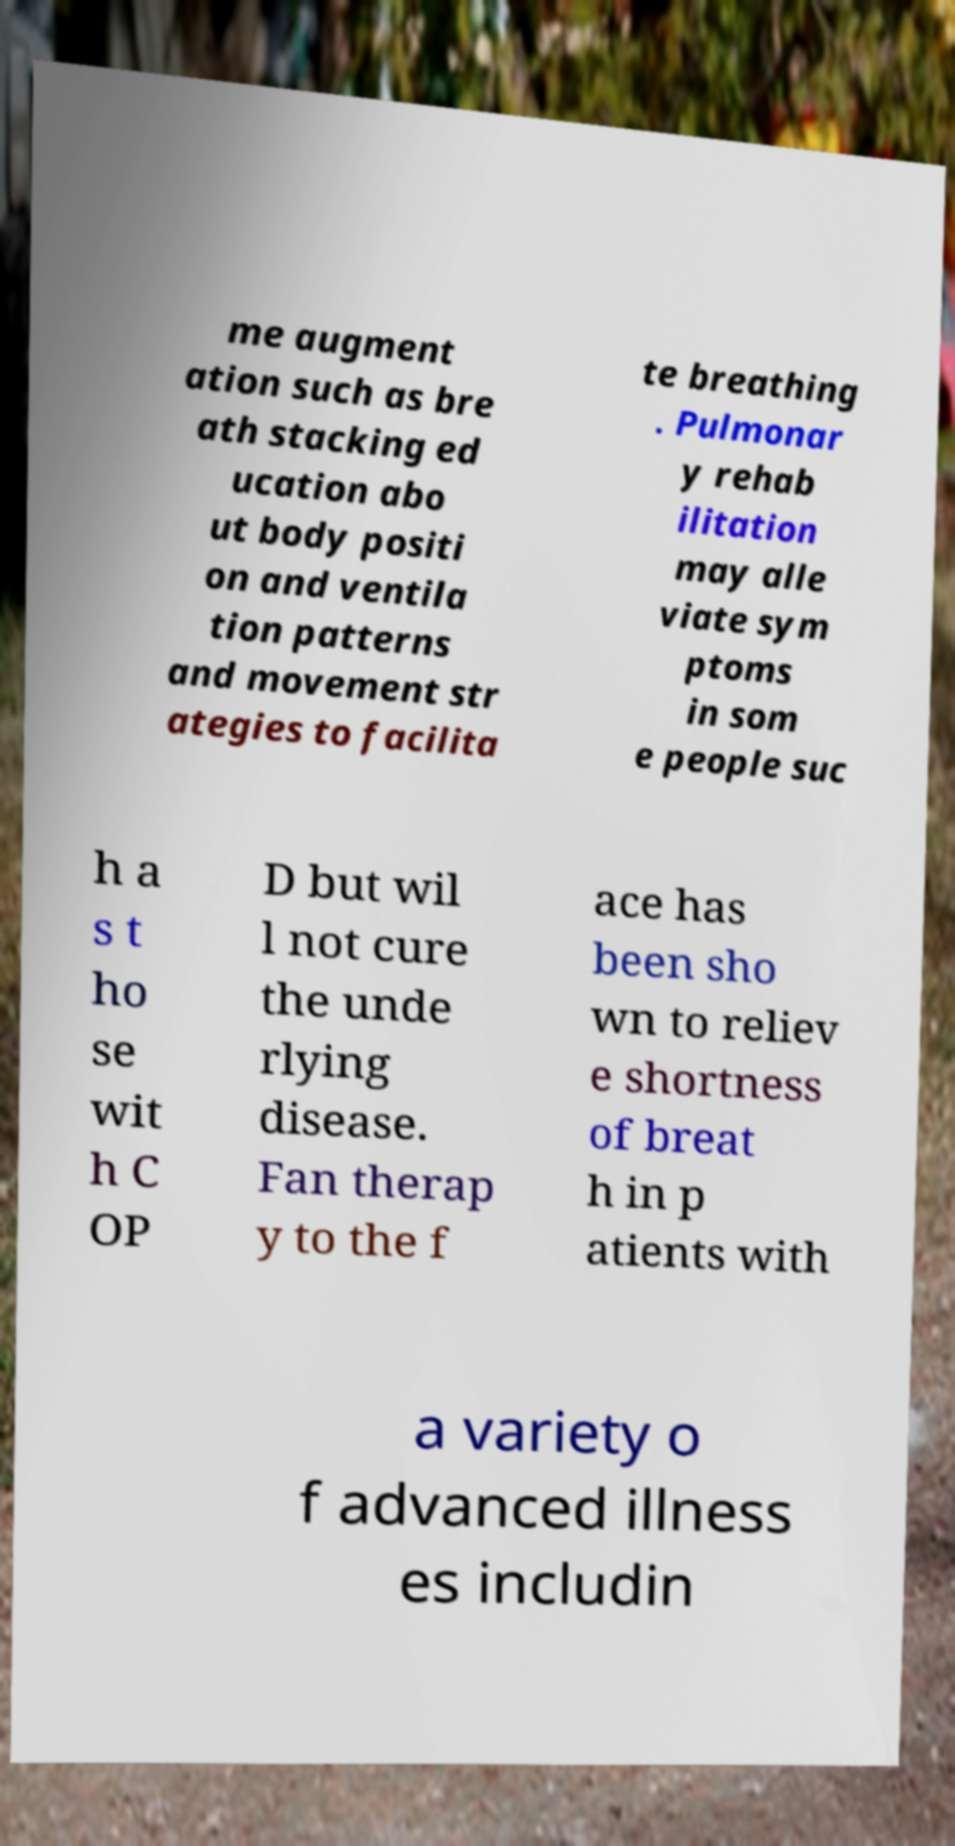What messages or text are displayed in this image? I need them in a readable, typed format. me augment ation such as bre ath stacking ed ucation abo ut body positi on and ventila tion patterns and movement str ategies to facilita te breathing . Pulmonar y rehab ilitation may alle viate sym ptoms in som e people suc h a s t ho se wit h C OP D but wil l not cure the unde rlying disease. Fan therap y to the f ace has been sho wn to reliev e shortness of breat h in p atients with a variety o f advanced illness es includin 